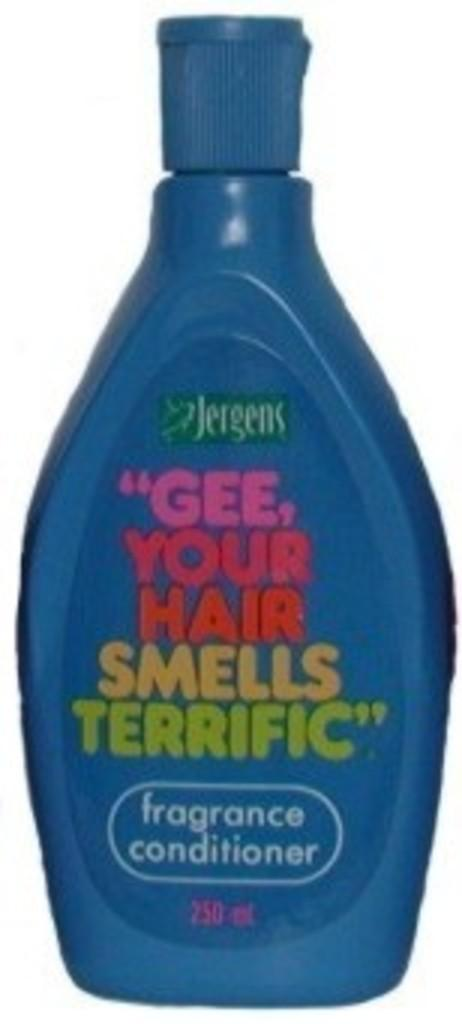<image>
Render a clear and concise summary of the photo. a blue plastic of fragrance conditioner by jergens 